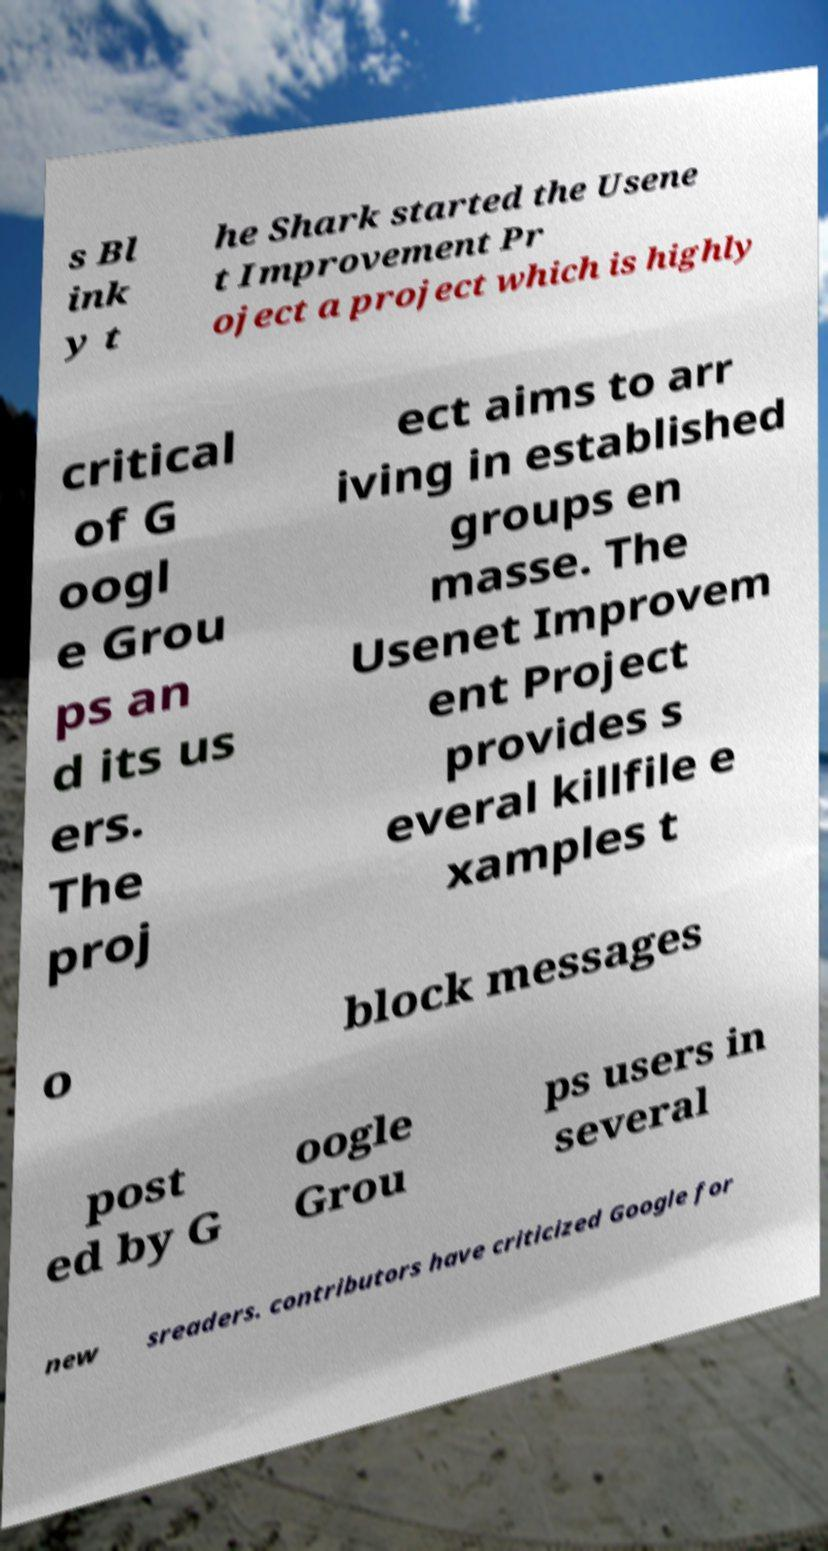Please read and relay the text visible in this image. What does it say? s Bl ink y t he Shark started the Usene t Improvement Pr oject a project which is highly critical of G oogl e Grou ps an d its us ers. The proj ect aims to arr iving in established groups en masse. The Usenet Improvem ent Project provides s everal killfile e xamples t o block messages post ed by G oogle Grou ps users in several new sreaders. contributors have criticized Google for 